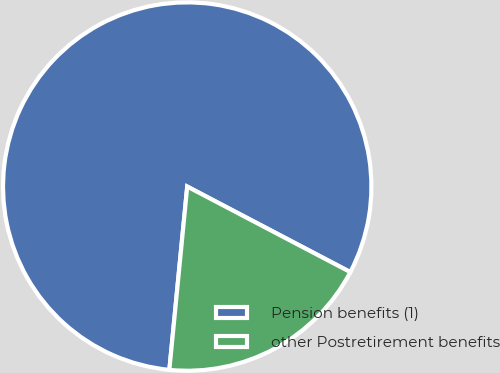Convert chart to OTSL. <chart><loc_0><loc_0><loc_500><loc_500><pie_chart><fcel>Pension benefits (1)<fcel>other Postretirement benefits<nl><fcel>81.14%<fcel>18.86%<nl></chart> 